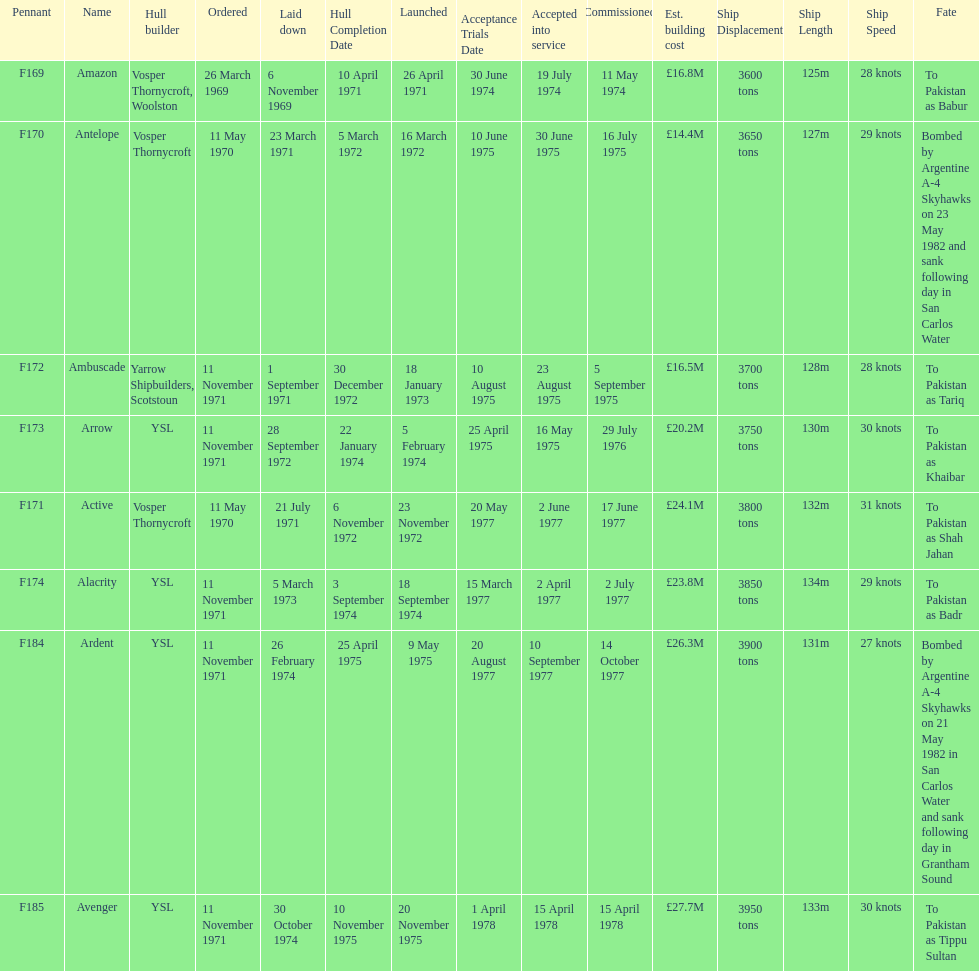How many boats costed less than £20m to build? 3. 